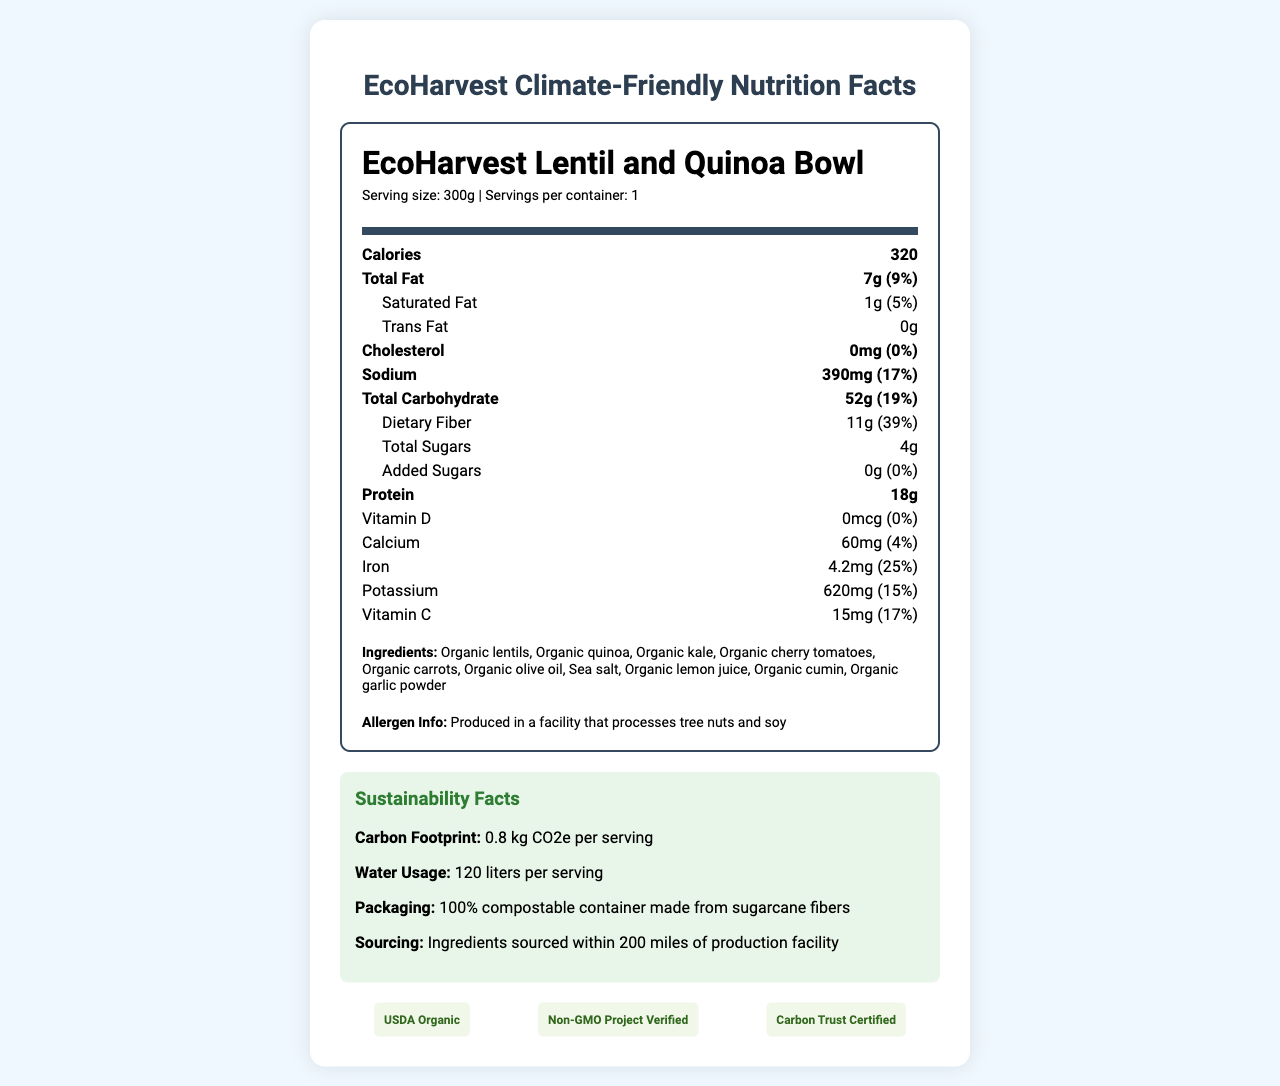what is the product name? The product name is clearly stated as "EcoHarvest Lentil and Quinoa Bowl" at the beginning of the document.
Answer: EcoHarvest Lentil and Quinoa Bowl what is the serving size of the product? The serving size is mentioned in the serving info section as "Serving size: 300g".
Answer: 300g how many calories are in one serving? The document states that the product contains 320 calories per serving.
Answer: 320 how much total fat is in one serving? The total fat content per serving is listed as 7g.
Answer: 7g how much sodium does the product contain? The document specifies that each serving contains 390mg of sodium.
Answer: 390mg which ingredient is NOT listed in the ingredients section? A. Organic kale B. Organic quinoa C. Organic chicken The ingredients section lists "Organic lentils", "Organic quinoa", "Organic kale", etc., but "Organic chicken" is not listed.
Answer: C what certifications does this product have? A. USDA Organic B. Non-GMO Project Verified C. Carbon Trust Certified D. All of the above The product is certified by USDA Organic, Non-GMO Project Verified, and Carbon Trust Certified.
Answer: D is the product free of trans fat? The document clearly states that the product contains 0g of trans fat.
Answer: Yes summarize the sustainability facts presented about the product. The sustainability facts section provides information on the carbon footprint, water usage, packaging, and sourcing for the product.
Answer: The product has a carbon footprint of 0.8 kg CO2e per serving and uses 120 liters of water per serving. It comes in 100% compostable containers made from sugarcane fibers, and all ingredients are sourced within 200 miles of the production facility. how much protein does the product contain per serving? The nutrition label specifies that the product contains 18g of protein per serving.
Answer: 18g what are the daily value percentages for dietary fiber? The daily value percentage for dietary fiber is 39%, as indicated in the document.
Answer: 39% what is the primary focus of the document? The main idea covers both nutrition facts and sustainability aspects, highlighting the product as eco-friendly and nutritious.
Answer: The document provides detailed nutrition and sustainability information about the EcoHarvest Lentil and Quinoa Bowl, including its ingredients, nutrient content, environmental impact, and certifications. what is the water usage per serving of the product? The water usage per serving for the product is given as 120 liters.
Answer: 120 liters can this product be sourced globally? The document mentions ingredient sourcing within 200 miles of the production facility but does not provide any information on global sourcing.
Answer: Not enough information 